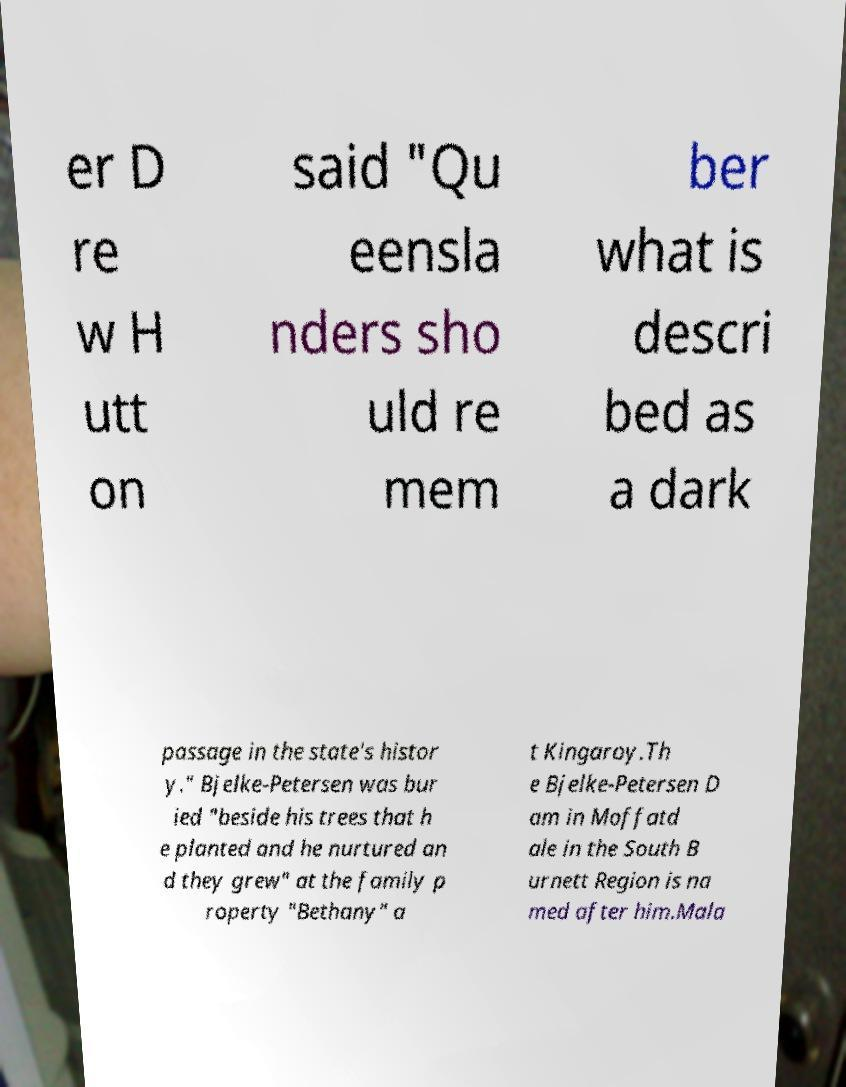Could you assist in decoding the text presented in this image and type it out clearly? er D re w H utt on said "Qu eensla nders sho uld re mem ber what is descri bed as a dark passage in the state's histor y." Bjelke-Petersen was bur ied "beside his trees that h e planted and he nurtured an d they grew" at the family p roperty "Bethany" a t Kingaroy.Th e Bjelke-Petersen D am in Moffatd ale in the South B urnett Region is na med after him.Mala 